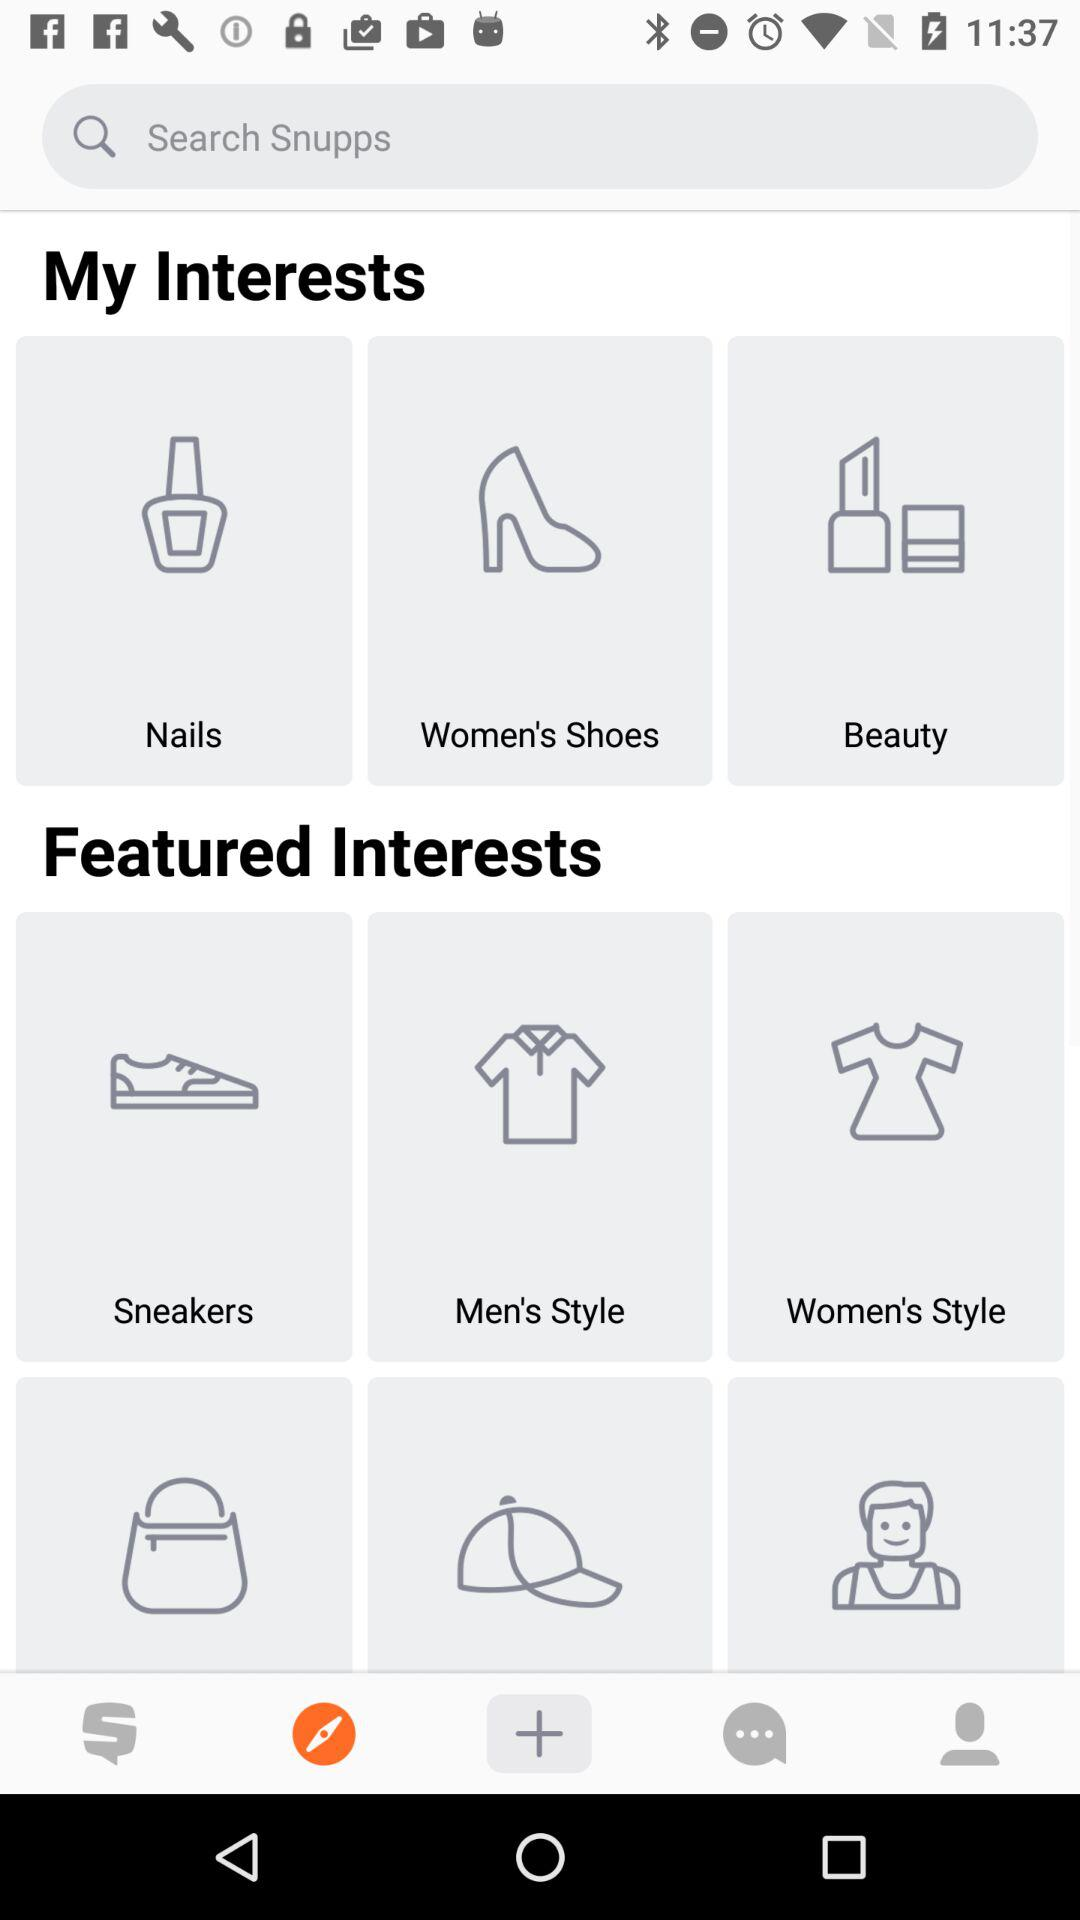What options are there in "Featured Interests"? The options are "Sneakers", "Men's Style" and "Women's Style". 